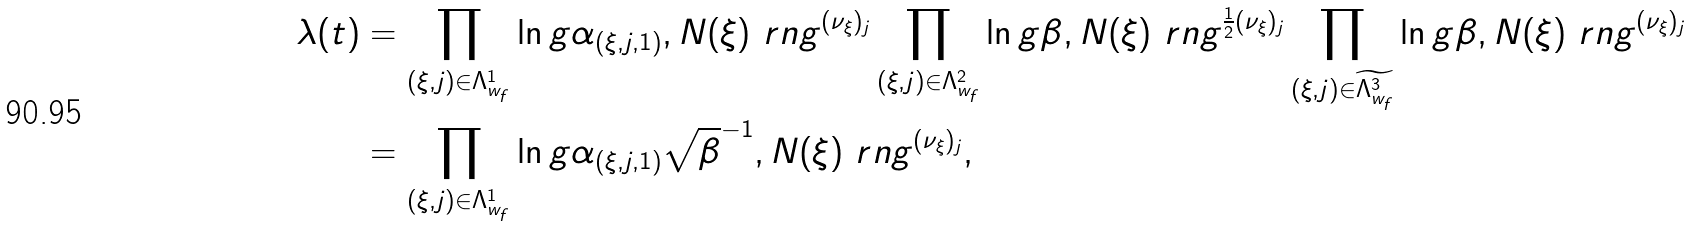<formula> <loc_0><loc_0><loc_500><loc_500>\lambda ( t ) & = \prod _ { ( \xi , j ) \in \Lambda _ { w _ { f } } ^ { 1 } } \ln g \alpha _ { ( \xi , j , 1 ) } , N ( \xi ) \ r n g ^ { ( \nu _ { \xi } ) _ { j } } \prod _ { ( \xi , j ) \in \Lambda _ { w _ { f } } ^ { 2 } } \ln g \beta , N ( \xi ) \ r n g ^ { \frac { 1 } { 2 } ( \nu _ { \xi } ) _ { j } } \prod _ { ( \xi , j ) \in \widetilde { \Lambda _ { w _ { f } } ^ { 3 } } } \ln g \beta , N ( \xi ) \ r n g ^ { ( \nu _ { \xi } ) _ { j } } \\ & = \prod _ { ( \xi , j ) \in \Lambda _ { w _ { f } } ^ { 1 } } \ln g \alpha _ { ( \xi , j , 1 ) } \sqrt { \beta } ^ { - 1 } , N ( \xi ) \ r n g ^ { ( \nu _ { \xi } ) _ { j } } ,</formula> 